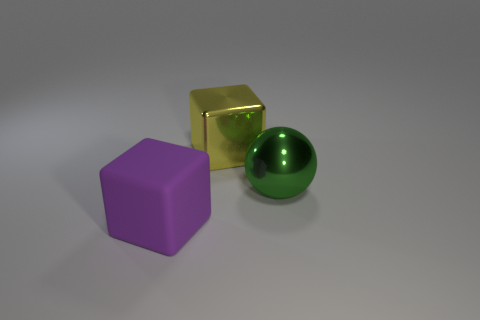Add 1 large blue metal objects. How many objects exist? 4 Subtract all balls. How many objects are left? 2 Add 1 small green matte objects. How many small green matte objects exist? 1 Subtract 0 blue cylinders. How many objects are left? 3 Subtract all large yellow metal blocks. Subtract all big metal things. How many objects are left? 0 Add 3 big yellow metal objects. How many big yellow metal objects are left? 4 